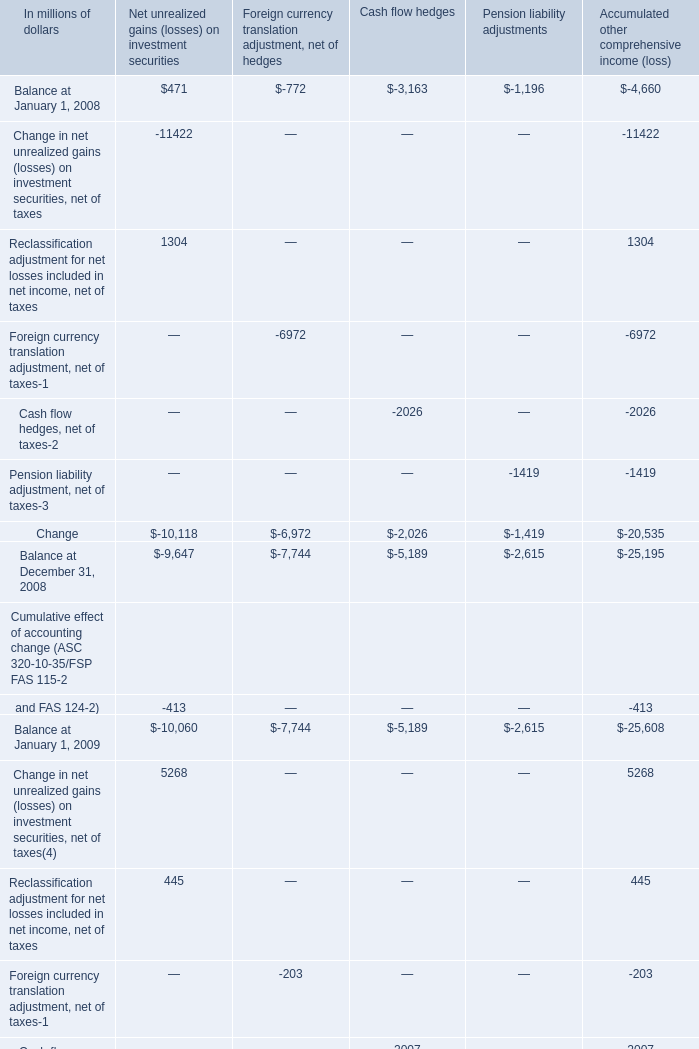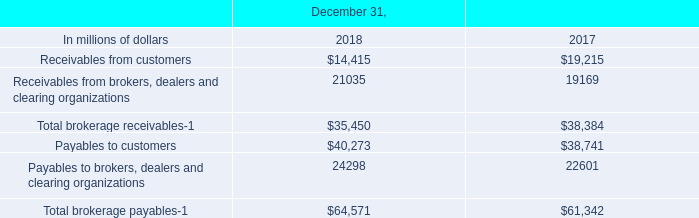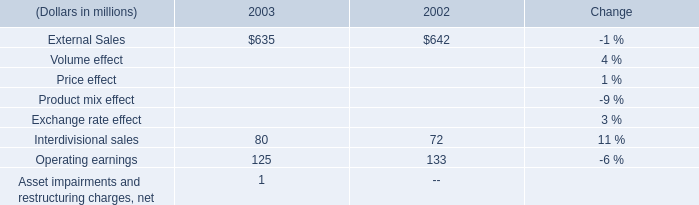What's the growth rate of Balance at December 31 in 2010? 
Computations: (((((-2395 + -7127) + -2650) + -4105) - (((-4347 + -7947) + -3182) + -3461)) / (((-4347 + -7947) + -3182) + -3461))
Answer: -0.14047. 